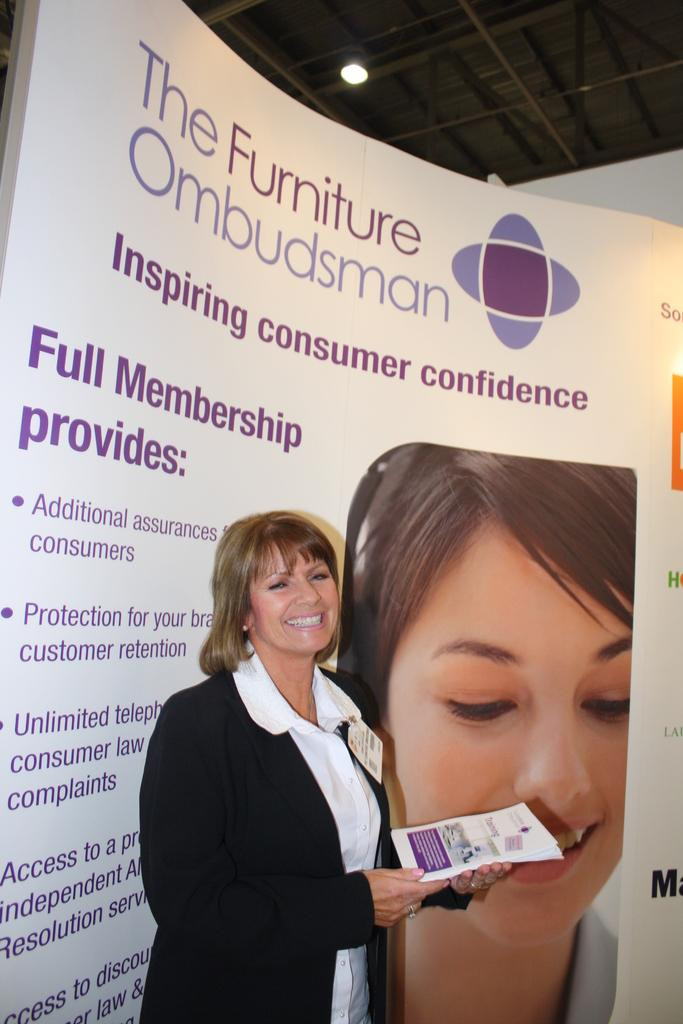Who is the main subject in the image? There is a lady in the center of the image. What is the lady doing in the image? The lady is standing and holding papers in her hand. What can be seen in the background of the image? There is a board in the background of the image. What architectural feature is visible in the image? There is a roof visible in the image. What is the source of light in the image? There is a light in the image. What hobbies does the pig in the image enjoy? There is no pig present in the image, so we cannot determine its hobbies. 